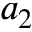<formula> <loc_0><loc_0><loc_500><loc_500>a _ { 2 }</formula> 